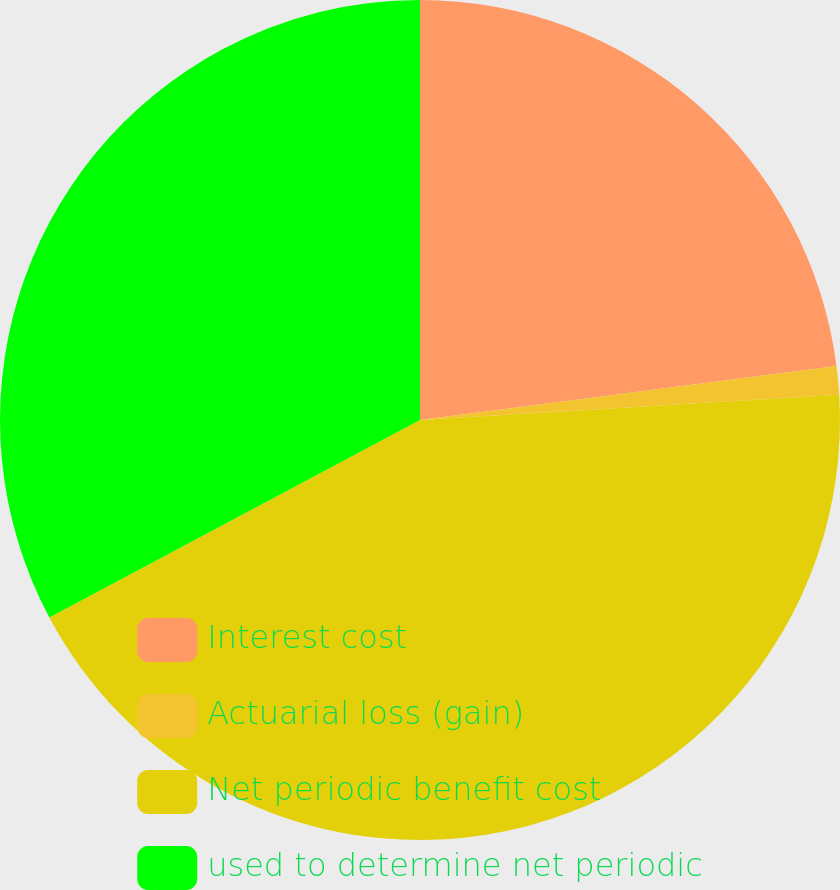Convert chart to OTSL. <chart><loc_0><loc_0><loc_500><loc_500><pie_chart><fcel>Interest cost<fcel>Actuarial loss (gain)<fcel>Net periodic benefit cost<fcel>used to determine net periodic<nl><fcel>22.95%<fcel>1.09%<fcel>43.17%<fcel>32.79%<nl></chart> 